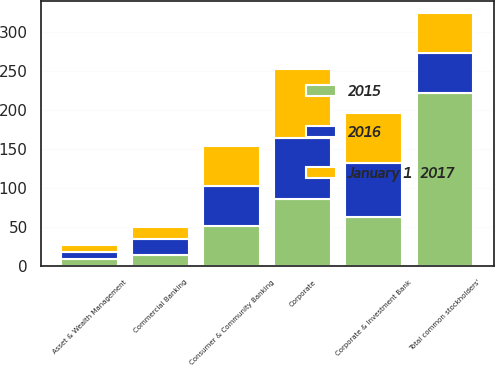<chart> <loc_0><loc_0><loc_500><loc_500><stacked_bar_chart><ecel><fcel>Consumer & Community Banking<fcel>Corporate & Investment Bank<fcel>Commercial Banking<fcel>Asset & Wealth Management<fcel>Corporate<fcel>Total common stockholders'<nl><fcel>2016<fcel>51<fcel>70<fcel>20<fcel>9<fcel>78.1<fcel>51<nl><fcel>January 1  2017<fcel>51<fcel>64<fcel>16<fcel>9<fcel>88.1<fcel>51<nl><fcel>2015<fcel>51<fcel>62<fcel>14<fcel>9<fcel>85.5<fcel>221.5<nl></chart> 